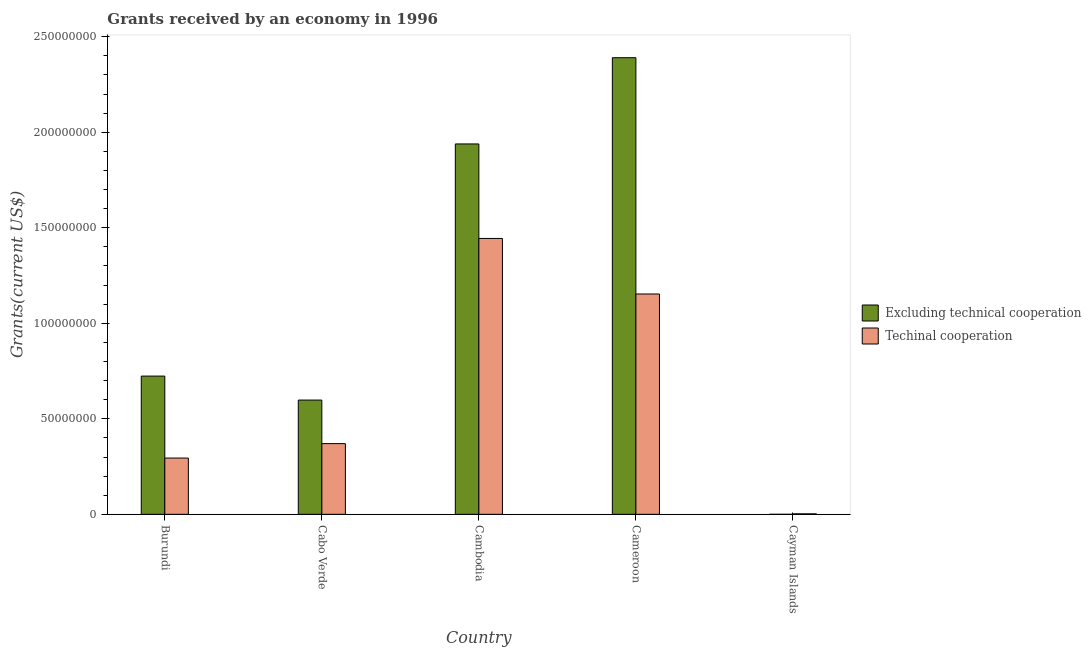How many different coloured bars are there?
Offer a terse response. 2. How many bars are there on the 1st tick from the left?
Keep it short and to the point. 2. How many bars are there on the 1st tick from the right?
Ensure brevity in your answer.  1. What is the label of the 3rd group of bars from the left?
Make the answer very short. Cambodia. In how many cases, is the number of bars for a given country not equal to the number of legend labels?
Your answer should be very brief. 1. What is the amount of grants received(excluding technical cooperation) in Burundi?
Offer a very short reply. 7.24e+07. Across all countries, what is the maximum amount of grants received(including technical cooperation)?
Provide a short and direct response. 1.44e+08. Across all countries, what is the minimum amount of grants received(including technical cooperation)?
Keep it short and to the point. 2.50e+05. In which country was the amount of grants received(including technical cooperation) maximum?
Provide a succinct answer. Cambodia. What is the total amount of grants received(including technical cooperation) in the graph?
Your answer should be compact. 3.26e+08. What is the difference between the amount of grants received(excluding technical cooperation) in Burundi and that in Cameroon?
Make the answer very short. -1.67e+08. What is the difference between the amount of grants received(including technical cooperation) in Cambodia and the amount of grants received(excluding technical cooperation) in Burundi?
Give a very brief answer. 7.20e+07. What is the average amount of grants received(including technical cooperation) per country?
Give a very brief answer. 6.53e+07. What is the difference between the amount of grants received(including technical cooperation) and amount of grants received(excluding technical cooperation) in Cabo Verde?
Your answer should be compact. -2.28e+07. In how many countries, is the amount of grants received(including technical cooperation) greater than 110000000 US$?
Offer a very short reply. 2. What is the ratio of the amount of grants received(including technical cooperation) in Burundi to that in Cameroon?
Keep it short and to the point. 0.26. Is the amount of grants received(excluding technical cooperation) in Burundi less than that in Cameroon?
Provide a succinct answer. Yes. What is the difference between the highest and the second highest amount of grants received(including technical cooperation)?
Offer a very short reply. 2.91e+07. What is the difference between the highest and the lowest amount of grants received(including technical cooperation)?
Give a very brief answer. 1.44e+08. How many bars are there?
Your answer should be very brief. 9. Are all the bars in the graph horizontal?
Give a very brief answer. No. Are the values on the major ticks of Y-axis written in scientific E-notation?
Make the answer very short. No. Does the graph contain any zero values?
Ensure brevity in your answer.  Yes. Where does the legend appear in the graph?
Provide a short and direct response. Center right. What is the title of the graph?
Give a very brief answer. Grants received by an economy in 1996. What is the label or title of the X-axis?
Your response must be concise. Country. What is the label or title of the Y-axis?
Make the answer very short. Grants(current US$). What is the Grants(current US$) in Excluding technical cooperation in Burundi?
Provide a succinct answer. 7.24e+07. What is the Grants(current US$) in Techinal cooperation in Burundi?
Give a very brief answer. 2.94e+07. What is the Grants(current US$) in Excluding technical cooperation in Cabo Verde?
Ensure brevity in your answer.  5.98e+07. What is the Grants(current US$) of Techinal cooperation in Cabo Verde?
Provide a short and direct response. 3.70e+07. What is the Grants(current US$) of Excluding technical cooperation in Cambodia?
Provide a succinct answer. 1.94e+08. What is the Grants(current US$) in Techinal cooperation in Cambodia?
Provide a succinct answer. 1.44e+08. What is the Grants(current US$) in Excluding technical cooperation in Cameroon?
Your answer should be very brief. 2.39e+08. What is the Grants(current US$) of Techinal cooperation in Cameroon?
Your answer should be very brief. 1.15e+08. Across all countries, what is the maximum Grants(current US$) of Excluding technical cooperation?
Give a very brief answer. 2.39e+08. Across all countries, what is the maximum Grants(current US$) of Techinal cooperation?
Your answer should be compact. 1.44e+08. Across all countries, what is the minimum Grants(current US$) in Excluding technical cooperation?
Ensure brevity in your answer.  0. Across all countries, what is the minimum Grants(current US$) of Techinal cooperation?
Give a very brief answer. 2.50e+05. What is the total Grants(current US$) of Excluding technical cooperation in the graph?
Your answer should be compact. 5.65e+08. What is the total Grants(current US$) in Techinal cooperation in the graph?
Provide a succinct answer. 3.26e+08. What is the difference between the Grants(current US$) in Excluding technical cooperation in Burundi and that in Cabo Verde?
Offer a terse response. 1.26e+07. What is the difference between the Grants(current US$) of Techinal cooperation in Burundi and that in Cabo Verde?
Your answer should be very brief. -7.56e+06. What is the difference between the Grants(current US$) of Excluding technical cooperation in Burundi and that in Cambodia?
Make the answer very short. -1.22e+08. What is the difference between the Grants(current US$) of Techinal cooperation in Burundi and that in Cambodia?
Provide a succinct answer. -1.15e+08. What is the difference between the Grants(current US$) in Excluding technical cooperation in Burundi and that in Cameroon?
Keep it short and to the point. -1.67e+08. What is the difference between the Grants(current US$) of Techinal cooperation in Burundi and that in Cameroon?
Your answer should be very brief. -8.59e+07. What is the difference between the Grants(current US$) of Techinal cooperation in Burundi and that in Cayman Islands?
Your answer should be compact. 2.92e+07. What is the difference between the Grants(current US$) in Excluding technical cooperation in Cabo Verde and that in Cambodia?
Give a very brief answer. -1.34e+08. What is the difference between the Grants(current US$) in Techinal cooperation in Cabo Verde and that in Cambodia?
Your answer should be very brief. -1.07e+08. What is the difference between the Grants(current US$) of Excluding technical cooperation in Cabo Verde and that in Cameroon?
Provide a succinct answer. -1.79e+08. What is the difference between the Grants(current US$) in Techinal cooperation in Cabo Verde and that in Cameroon?
Offer a terse response. -7.83e+07. What is the difference between the Grants(current US$) in Techinal cooperation in Cabo Verde and that in Cayman Islands?
Give a very brief answer. 3.68e+07. What is the difference between the Grants(current US$) of Excluding technical cooperation in Cambodia and that in Cameroon?
Your answer should be very brief. -4.51e+07. What is the difference between the Grants(current US$) of Techinal cooperation in Cambodia and that in Cameroon?
Keep it short and to the point. 2.91e+07. What is the difference between the Grants(current US$) in Techinal cooperation in Cambodia and that in Cayman Islands?
Your answer should be compact. 1.44e+08. What is the difference between the Grants(current US$) of Techinal cooperation in Cameroon and that in Cayman Islands?
Give a very brief answer. 1.15e+08. What is the difference between the Grants(current US$) of Excluding technical cooperation in Burundi and the Grants(current US$) of Techinal cooperation in Cabo Verde?
Offer a very short reply. 3.54e+07. What is the difference between the Grants(current US$) of Excluding technical cooperation in Burundi and the Grants(current US$) of Techinal cooperation in Cambodia?
Keep it short and to the point. -7.20e+07. What is the difference between the Grants(current US$) in Excluding technical cooperation in Burundi and the Grants(current US$) in Techinal cooperation in Cameroon?
Your answer should be compact. -4.30e+07. What is the difference between the Grants(current US$) of Excluding technical cooperation in Burundi and the Grants(current US$) of Techinal cooperation in Cayman Islands?
Give a very brief answer. 7.21e+07. What is the difference between the Grants(current US$) of Excluding technical cooperation in Cabo Verde and the Grants(current US$) of Techinal cooperation in Cambodia?
Offer a terse response. -8.46e+07. What is the difference between the Grants(current US$) in Excluding technical cooperation in Cabo Verde and the Grants(current US$) in Techinal cooperation in Cameroon?
Ensure brevity in your answer.  -5.55e+07. What is the difference between the Grants(current US$) in Excluding technical cooperation in Cabo Verde and the Grants(current US$) in Techinal cooperation in Cayman Islands?
Your answer should be very brief. 5.96e+07. What is the difference between the Grants(current US$) in Excluding technical cooperation in Cambodia and the Grants(current US$) in Techinal cooperation in Cameroon?
Your answer should be compact. 7.85e+07. What is the difference between the Grants(current US$) of Excluding technical cooperation in Cambodia and the Grants(current US$) of Techinal cooperation in Cayman Islands?
Your answer should be very brief. 1.94e+08. What is the difference between the Grants(current US$) in Excluding technical cooperation in Cameroon and the Grants(current US$) in Techinal cooperation in Cayman Islands?
Ensure brevity in your answer.  2.39e+08. What is the average Grants(current US$) in Excluding technical cooperation per country?
Offer a very short reply. 1.13e+08. What is the average Grants(current US$) in Techinal cooperation per country?
Provide a short and direct response. 6.53e+07. What is the difference between the Grants(current US$) in Excluding technical cooperation and Grants(current US$) in Techinal cooperation in Burundi?
Your response must be concise. 4.29e+07. What is the difference between the Grants(current US$) in Excluding technical cooperation and Grants(current US$) in Techinal cooperation in Cabo Verde?
Give a very brief answer. 2.28e+07. What is the difference between the Grants(current US$) in Excluding technical cooperation and Grants(current US$) in Techinal cooperation in Cambodia?
Give a very brief answer. 4.95e+07. What is the difference between the Grants(current US$) of Excluding technical cooperation and Grants(current US$) of Techinal cooperation in Cameroon?
Your response must be concise. 1.24e+08. What is the ratio of the Grants(current US$) in Excluding technical cooperation in Burundi to that in Cabo Verde?
Provide a short and direct response. 1.21. What is the ratio of the Grants(current US$) in Techinal cooperation in Burundi to that in Cabo Verde?
Make the answer very short. 0.8. What is the ratio of the Grants(current US$) in Excluding technical cooperation in Burundi to that in Cambodia?
Ensure brevity in your answer.  0.37. What is the ratio of the Grants(current US$) in Techinal cooperation in Burundi to that in Cambodia?
Ensure brevity in your answer.  0.2. What is the ratio of the Grants(current US$) of Excluding technical cooperation in Burundi to that in Cameroon?
Offer a very short reply. 0.3. What is the ratio of the Grants(current US$) in Techinal cooperation in Burundi to that in Cameroon?
Provide a short and direct response. 0.26. What is the ratio of the Grants(current US$) of Techinal cooperation in Burundi to that in Cayman Islands?
Give a very brief answer. 117.8. What is the ratio of the Grants(current US$) in Excluding technical cooperation in Cabo Verde to that in Cambodia?
Your response must be concise. 0.31. What is the ratio of the Grants(current US$) in Techinal cooperation in Cabo Verde to that in Cambodia?
Your answer should be compact. 0.26. What is the ratio of the Grants(current US$) of Excluding technical cooperation in Cabo Verde to that in Cameroon?
Your answer should be compact. 0.25. What is the ratio of the Grants(current US$) of Techinal cooperation in Cabo Verde to that in Cameroon?
Provide a succinct answer. 0.32. What is the ratio of the Grants(current US$) in Techinal cooperation in Cabo Verde to that in Cayman Islands?
Provide a succinct answer. 148.04. What is the ratio of the Grants(current US$) of Excluding technical cooperation in Cambodia to that in Cameroon?
Your answer should be compact. 0.81. What is the ratio of the Grants(current US$) of Techinal cooperation in Cambodia to that in Cameroon?
Ensure brevity in your answer.  1.25. What is the ratio of the Grants(current US$) in Techinal cooperation in Cambodia to that in Cayman Islands?
Provide a succinct answer. 577.6. What is the ratio of the Grants(current US$) of Techinal cooperation in Cameroon to that in Cayman Islands?
Provide a short and direct response. 461.32. What is the difference between the highest and the second highest Grants(current US$) in Excluding technical cooperation?
Keep it short and to the point. 4.51e+07. What is the difference between the highest and the second highest Grants(current US$) in Techinal cooperation?
Keep it short and to the point. 2.91e+07. What is the difference between the highest and the lowest Grants(current US$) in Excluding technical cooperation?
Make the answer very short. 2.39e+08. What is the difference between the highest and the lowest Grants(current US$) of Techinal cooperation?
Offer a terse response. 1.44e+08. 